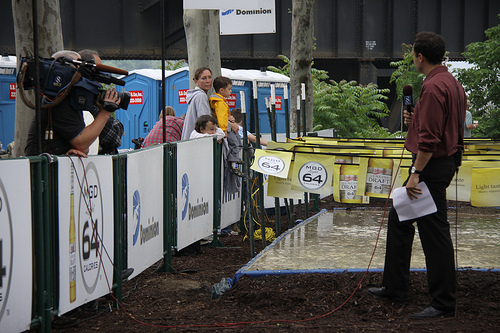<image>
Is the camera on the man? Yes. Looking at the image, I can see the camera is positioned on top of the man, with the man providing support. Is there a tree behind the man? Yes. From this viewpoint, the tree is positioned behind the man, with the man partially or fully occluding the tree. 